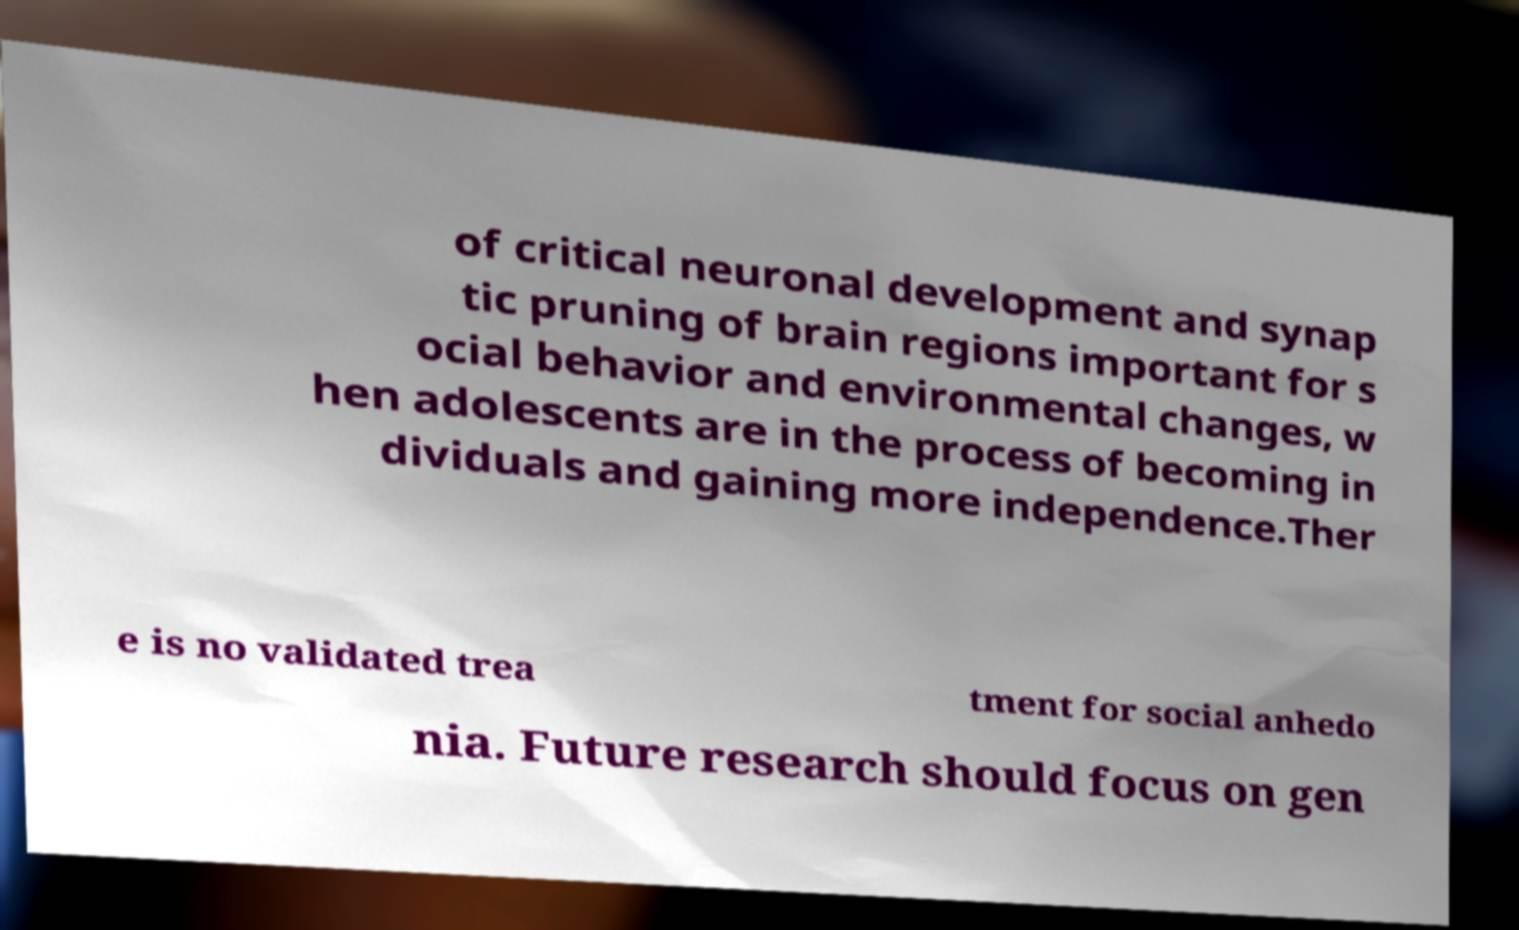Please read and relay the text visible in this image. What does it say? of critical neuronal development and synap tic pruning of brain regions important for s ocial behavior and environmental changes, w hen adolescents are in the process of becoming in dividuals and gaining more independence.Ther e is no validated trea tment for social anhedo nia. Future research should focus on gen 